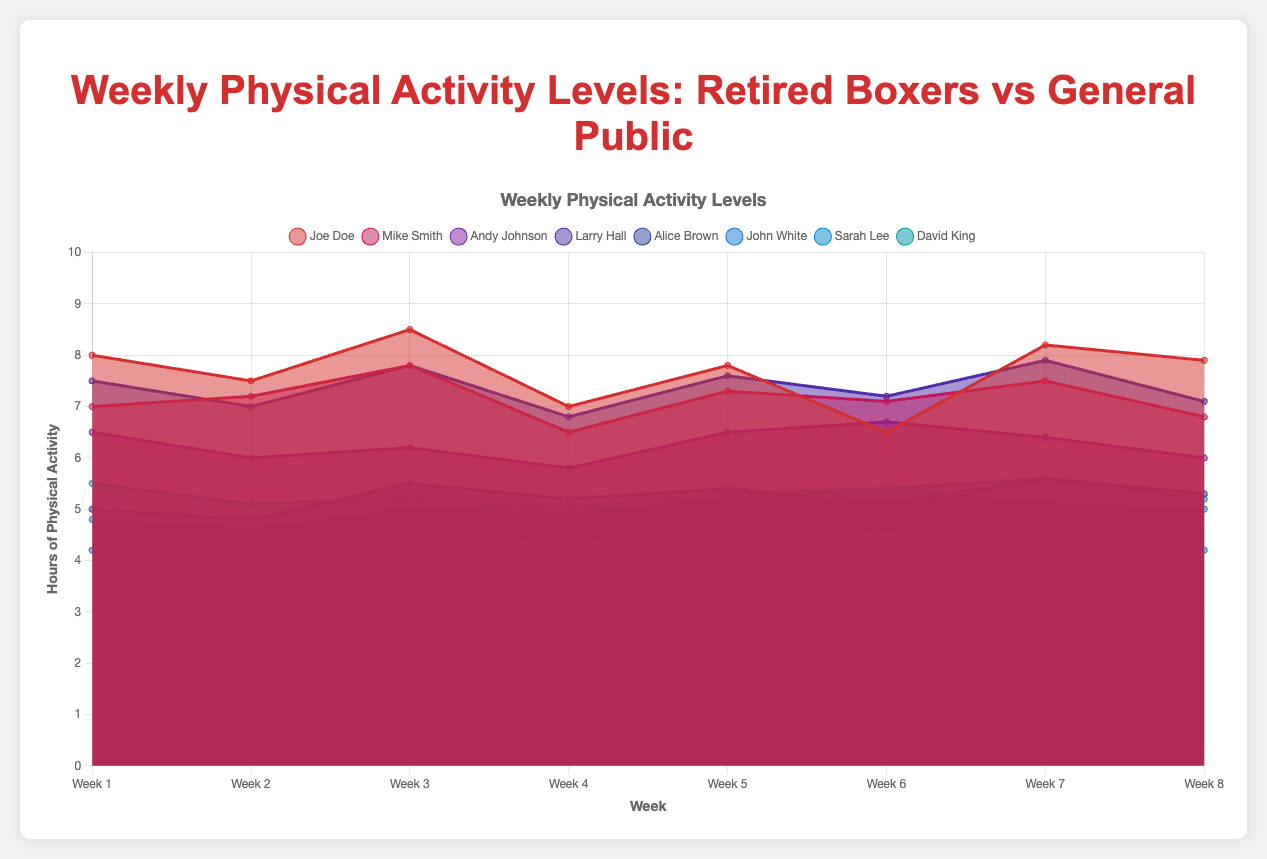What's the title of the chart? The title is typically positioned at the top of the chart, clearly indicating the content being visualized.
Answer: Weekly Physical Activity Levels: Retired Boxers vs General Public How many weeks are displayed in the chart? The number of weeks can be counted along the x-axis, as each week label represents a data point.
Answer: 8 Which retired boxer has the highest physical activity level in Week 4? Look at the values and the height of the areas for each retired boxer at Week 4.
Answer: Joe Doe What is the average physical activity level of Joe Doe across all weeks? Sum up Joe Doe's weekly values and divide by the number of weeks: (8 + 7.5 + 8.5 + 7 + 7.8 + 6.5 + 8.2 + 7.9) / 8 = 61.4 / 8.
Answer: 7.675 Who had the lowest level of physical activity in Week 3 among the general public? Compare the values and the height of the areas for each person in the general public at Week 3, finding the lowest one.
Answer: John White What's the difference in physical activity levels between Mike Smith and David King in Week 7? Find the values for both individuals in Week 7 and calculate the difference: 7.5 - 5.6 = 1.9.
Answer: 1.9 Which group, retired boxers or the general public, generally engages in more physical activity? Compare the general trends in the levels of physical activity across weeks for both groups.
Answer: Retired boxers Which retired boxer showed the most significant fluctuation in physical activity levels across the weeks? Evaluate the variability in the physical activity levels for each retired boxer, comparing the difference between the highest and lowest points.
Answer: Joe Doe By how much did Alice Brown's physical activity level change from Week 1 to Week 2? Subtract Week 1's value from Week 2's value for Alice Brown: 4.8 - 5 = -0.2.
Answer: -0.2 